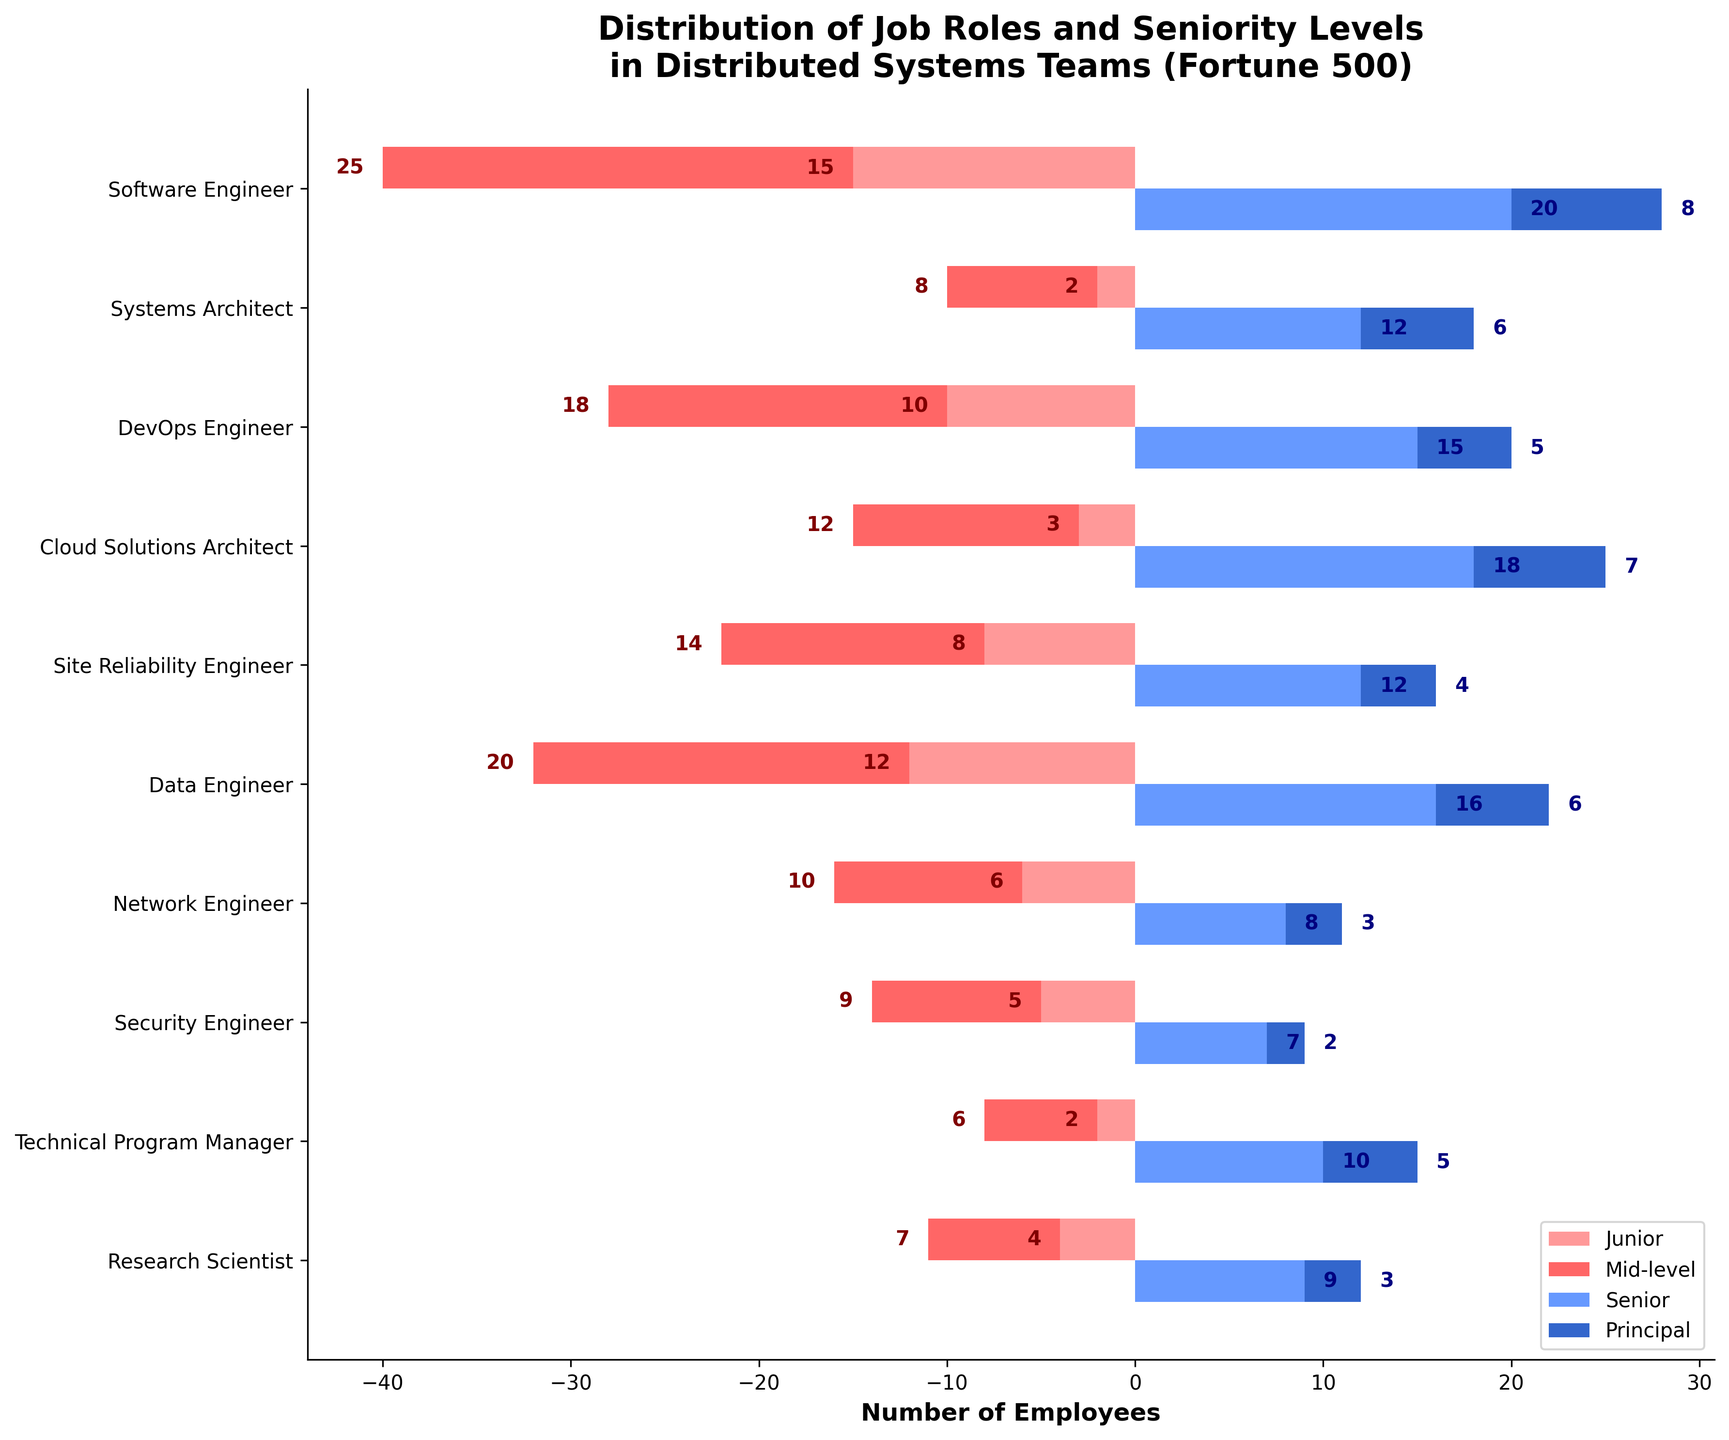what is the title of the pyramid plot? The title is located at the top of the plot and provides a summary of what the plot represents
Answer: Distribution of Job Roles and Seniority Levels in Distributed Systems Teams (Fortune 500) Which job role has the highest number of Junior employees? By examining the left side of the pyramid plot, we can compare the lengths of the red bars representing Junior employees
Answer: Software Engineer How many Principal Cloud Solutions Architects are there? Look at the Principal section (dark blue bar) on the right side of the pyramid to find the corresponding role
Answer: 7 What’s the total number of employees in the Software Engineer role? Sum the numbers of Junior, Mid-level, Senior, and Principal employees for this role: 15 + 25 + 20 + 8
Answer: 68 Which roles have fewer Principal employees than Senior employees? Compare the Principal and Senior bars for each role to see which ones have fewer Principal employees
Answer: Software Engineer, Systems Architect, DevOps Engineer, Cloud Solutions Architect, Site Reliability Engineer, Data Engineer, Network Engineer, Security Engineer, Technical Program Manager, Research Scientist For the role of Site Reliability Engineer, is the number of Mid-level employees greater than the number of Senior employees? Compare the length of the pink and light blue bars for Site Reliability Engineer
Answer: Yes Which role has the smallest number of Mid-level employees? Look for the shortest light red bar in the Mid-level category
Answer: Security Engineer Between Data Engineer and DevOps Engineer, which role has more Junior employees? Compare the lengths of the red bars for Data Engineer and DevOps Engineer
Answer: Data Engineer What's the combined number of Principal and Senior employees for the role of Technical Program Manager? Sum the numbers of Senior and Principal employees for this role: 10 + 5
Answer: 15 Are there more Senior or Junior employees in the role of Research Scientist? Compare the lengths of the red and light blue bars for the Research Scientist role
Answer: More Senior 